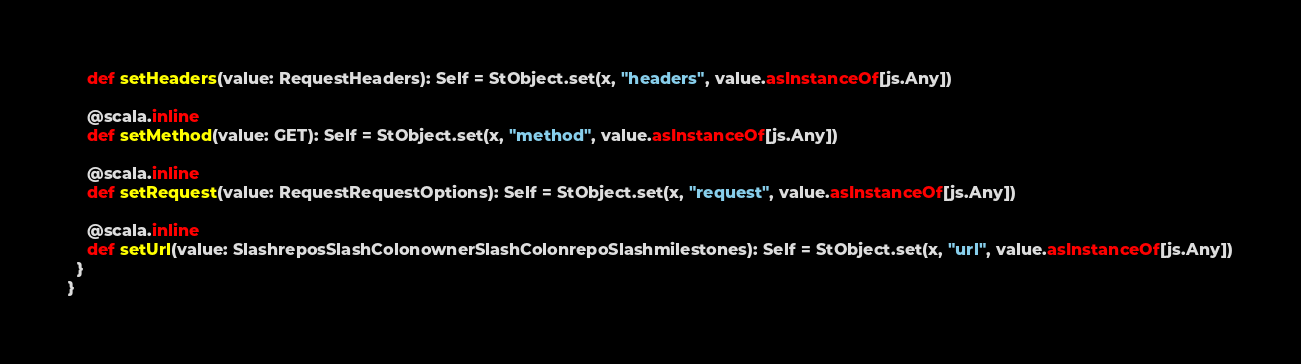Convert code to text. <code><loc_0><loc_0><loc_500><loc_500><_Scala_>    def setHeaders(value: RequestHeaders): Self = StObject.set(x, "headers", value.asInstanceOf[js.Any])
    
    @scala.inline
    def setMethod(value: GET): Self = StObject.set(x, "method", value.asInstanceOf[js.Any])
    
    @scala.inline
    def setRequest(value: RequestRequestOptions): Self = StObject.set(x, "request", value.asInstanceOf[js.Any])
    
    @scala.inline
    def setUrl(value: SlashreposSlashColonownerSlashColonrepoSlashmilestones): Self = StObject.set(x, "url", value.asInstanceOf[js.Any])
  }
}
</code> 